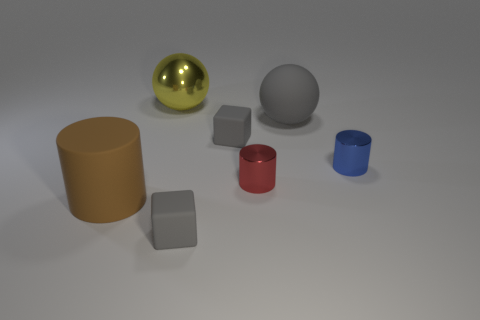How many tiny cubes have the same material as the tiny red cylinder?
Your response must be concise. 0. Are there fewer yellow things that are behind the rubber ball than blue metal cylinders?
Offer a terse response. No. There is a rubber object that is in front of the matte thing to the left of the shiny ball; how big is it?
Provide a short and direct response. Small. Is the color of the large shiny object the same as the metallic cylinder right of the big gray thing?
Provide a succinct answer. No. There is a red cylinder that is the same size as the blue cylinder; what is it made of?
Your answer should be very brief. Metal. Are there fewer rubber cubes that are behind the tiny blue metallic cylinder than yellow shiny balls that are in front of the brown rubber cylinder?
Your answer should be very brief. No. What is the shape of the gray thing that is left of the tiny rubber cube that is behind the brown matte thing?
Keep it short and to the point. Cube. Is there a tiny blue shiny block?
Give a very brief answer. No. There is a metallic cylinder that is right of the large matte sphere; what color is it?
Your response must be concise. Blue. Are there any red cylinders on the left side of the metallic ball?
Offer a very short reply. No. 